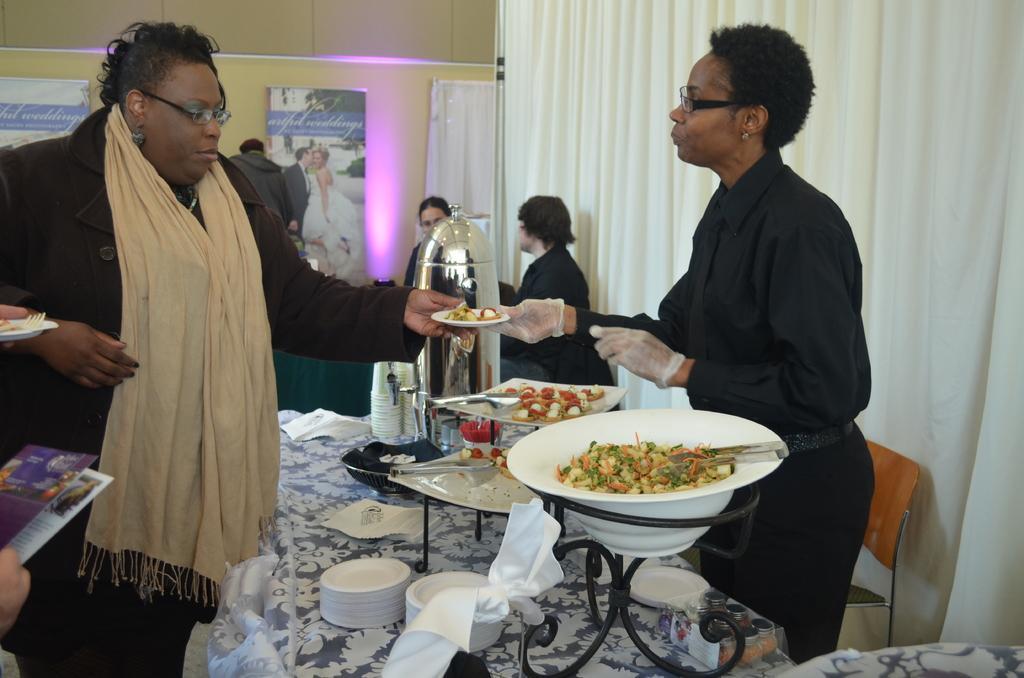Can you describe this image briefly? In this picture there is a dining table in the center of the image, which contains bowls, flask, and other food items on it, there is a lady who is standing on the left side of the image and there are other people in the center of the image, there is a white color curtain and a chair on the right side of the image. 